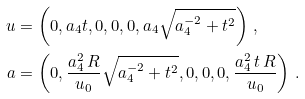<formula> <loc_0><loc_0><loc_500><loc_500>u & = \left ( 0 , a _ { 4 } t , 0 , 0 , 0 , a _ { 4 } \sqrt { a _ { 4 } ^ { - 2 } + t ^ { 2 } } \right ) \, , \\ a & = \left ( 0 , \frac { a _ { 4 } ^ { 2 } \, R } { u _ { 0 } } \sqrt { a _ { 4 } ^ { - 2 } + t ^ { 2 } } , 0 , 0 , 0 , \frac { a _ { 4 } ^ { 2 } \, t \, R } { u _ { 0 } } \right ) \, .</formula> 